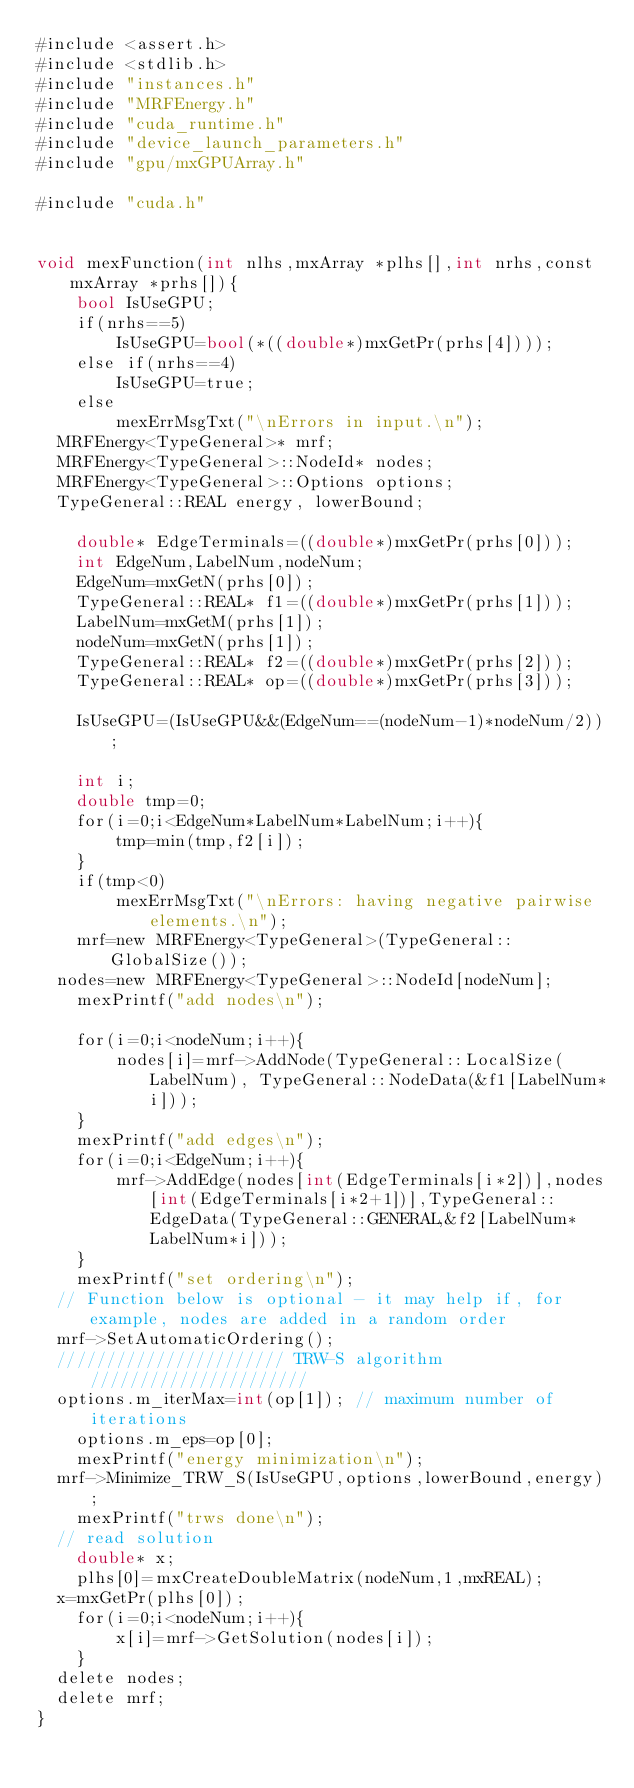Convert code to text. <code><loc_0><loc_0><loc_500><loc_500><_Cuda_>#include <assert.h>
#include <stdlib.h>
#include "instances.h"
#include "MRFEnergy.h"
#include "cuda_runtime.h"
#include "device_launch_parameters.h"
#include "gpu/mxGPUArray.h"

#include "cuda.h"


void mexFunction(int nlhs,mxArray *plhs[],int nrhs,const mxArray *prhs[]){
    bool IsUseGPU;
    if(nrhs==5)
        IsUseGPU=bool(*((double*)mxGetPr(prhs[4])));
    else if(nrhs==4)
        IsUseGPU=true;
    else
        mexErrMsgTxt("\nErrors in input.\n");
	MRFEnergy<TypeGeneral>* mrf;
	MRFEnergy<TypeGeneral>::NodeId* nodes;
	MRFEnergy<TypeGeneral>::Options options;
	TypeGeneral::REAL energy, lowerBound;

    double* EdgeTerminals=((double*)mxGetPr(prhs[0]));
    int EdgeNum,LabelNum,nodeNum;
    EdgeNum=mxGetN(prhs[0]);
    TypeGeneral::REAL* f1=((double*)mxGetPr(prhs[1]));
    LabelNum=mxGetM(prhs[1]);
    nodeNum=mxGetN(prhs[1]);
    TypeGeneral::REAL* f2=((double*)mxGetPr(prhs[2]));
    TypeGeneral::REAL* op=((double*)mxGetPr(prhs[3]));
    
    IsUseGPU=(IsUseGPU&&(EdgeNum==(nodeNum-1)*nodeNum/2));

    int i;
    double tmp=0;
    for(i=0;i<EdgeNum*LabelNum*LabelNum;i++){
        tmp=min(tmp,f2[i]);
    }
    if(tmp<0)
        mexErrMsgTxt("\nErrors: having negative pairwise elements.\n");
    mrf=new MRFEnergy<TypeGeneral>(TypeGeneral::GlobalSize());
	nodes=new MRFEnergy<TypeGeneral>::NodeId[nodeNum];
    mexPrintf("add nodes\n");
	
    for(i=0;i<nodeNum;i++){
        nodes[i]=mrf->AddNode(TypeGeneral::LocalSize(LabelNum), TypeGeneral::NodeData(&f1[LabelNum*i]));
    }
    mexPrintf("add edges\n");
    for(i=0;i<EdgeNum;i++){
        mrf->AddEdge(nodes[int(EdgeTerminals[i*2])],nodes[int(EdgeTerminals[i*2+1])],TypeGeneral::EdgeData(TypeGeneral::GENERAL,&f2[LabelNum*LabelNum*i]));
    }
    mexPrintf("set ordering\n");
	// Function below is optional - it may help if, for example, nodes are added in a random order
	mrf->SetAutomaticOrdering();
	/////////////////////// TRW-S algorithm //////////////////////
	options.m_iterMax=int(op[1]); // maximum number of iterations
    options.m_eps=op[0];
    mexPrintf("energy minimization\n");
	mrf->Minimize_TRW_S(IsUseGPU,options,lowerBound,energy);
    mexPrintf("trws done\n");
	// read solution
    double* x;
    plhs[0]=mxCreateDoubleMatrix(nodeNum,1,mxREAL);
	x=mxGetPr(plhs[0]);
    for(i=0;i<nodeNum;i++){
        x[i]=mrf->GetSolution(nodes[i]);
    }
	delete nodes;
	delete mrf;
}
</code> 